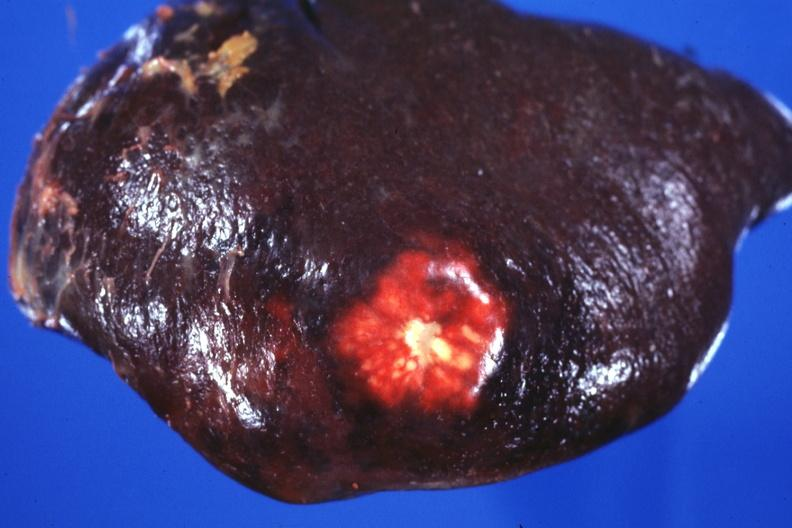where is this part in?
Answer the question using a single word or phrase. Spleen 